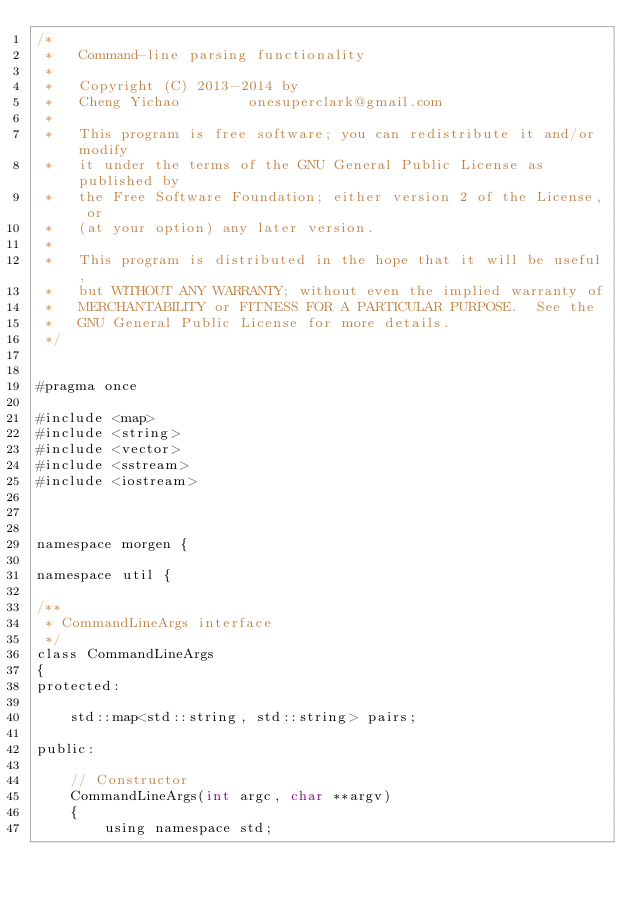Convert code to text. <code><loc_0><loc_0><loc_500><loc_500><_Cuda_>/*
 *   Command-line parsing functionality
 *
 *   Copyright (C) 2013-2014 by
 *   Cheng Yichao        onesuperclark@gmail.com
 *
 *   This program is free software; you can redistribute it and/or modify
 *   it under the terms of the GNU General Public License as published by
 *   the Free Software Foundation; either version 2 of the License, or
 *   (at your option) any later version.
 *
 *   This program is distributed in the hope that it will be useful,
 *   but WITHOUT ANY WARRANTY; without even the implied warranty of
 *   MERCHANTABILITY or FITNESS FOR A PARTICULAR PURPOSE.  See the
 *   GNU General Public License for more details.
 */


#pragma once

#include <map>
#include <string>
#include <vector>
#include <sstream>
#include <iostream>



namespace morgen {

namespace util {

/**
 * CommandLineArgs interface
 */
class CommandLineArgs
{
protected:

    std::map<std::string, std::string> pairs;

public:

    // Constructor
    CommandLineArgs(int argc, char **argv)
    {
        using namespace std;
</code> 